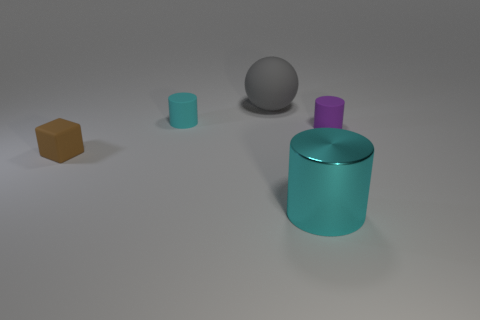Add 3 small red matte cylinders. How many objects exist? 8 Subtract all cylinders. How many objects are left? 2 Add 1 tiny yellow cylinders. How many tiny yellow cylinders exist? 1 Subtract 0 cyan balls. How many objects are left? 5 Subtract all tiny blue metallic spheres. Subtract all small purple rubber cylinders. How many objects are left? 4 Add 5 rubber cylinders. How many rubber cylinders are left? 7 